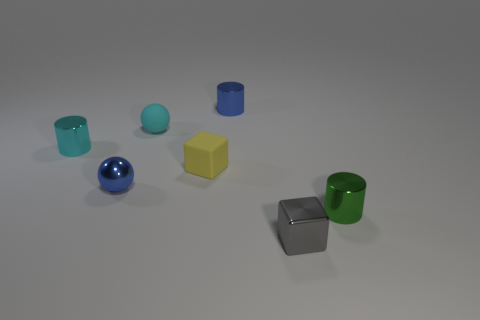Subtract all small cyan cylinders. How many cylinders are left? 2 Add 2 big yellow shiny balls. How many objects exist? 9 Subtract 1 cylinders. How many cylinders are left? 2 Subtract all cubes. How many objects are left? 5 Subtract all red cylinders. Subtract all brown balls. How many cylinders are left? 3 Add 1 tiny cylinders. How many tiny cylinders are left? 4 Add 5 small matte blocks. How many small matte blocks exist? 6 Subtract 0 gray balls. How many objects are left? 7 Subtract all yellow shiny objects. Subtract all small green shiny cylinders. How many objects are left? 6 